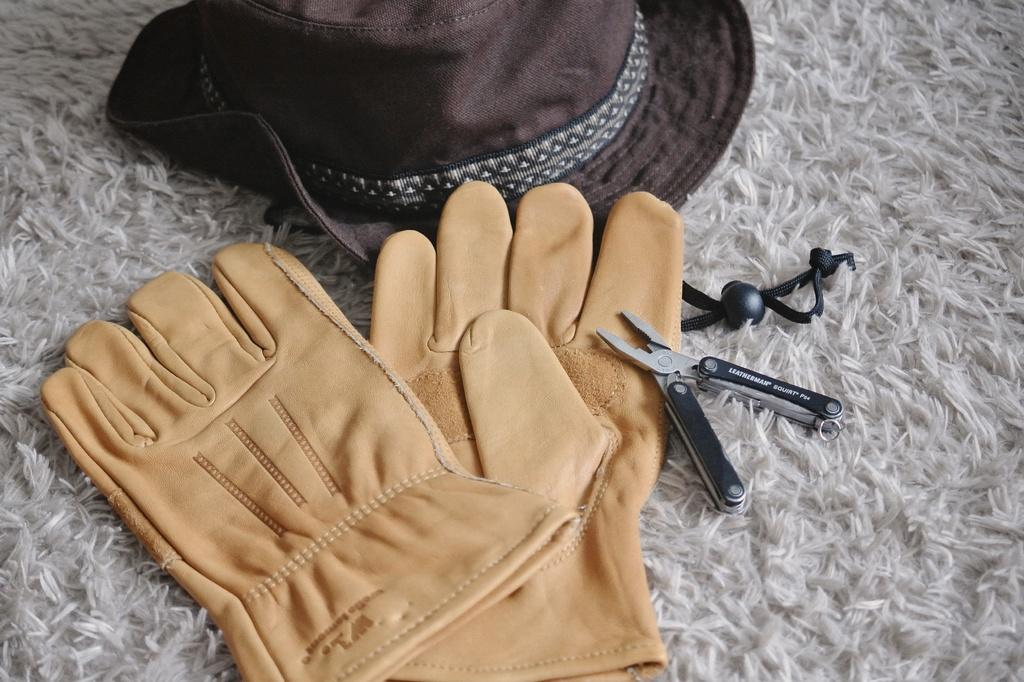What type of clothing accessory is present in the image? There is a hat in the image. What other accessory can be seen in the image? There are gloves in the image. What tool is visible in the image? There is a cutter in the image. Where are these objects located in the image? These objects are present on a floor mat. What type of coast can be seen in the image? There is no coast present in the image; it features a hat, gloves, cutter, and a floor mat. How quiet is the stove in the image? There is no stove present in the image, so it cannot be determined how quiet it might be. 